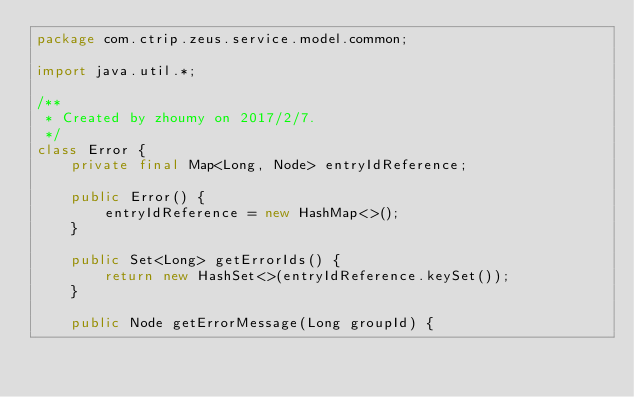<code> <loc_0><loc_0><loc_500><loc_500><_Java_>package com.ctrip.zeus.service.model.common;

import java.util.*;

/**
 * Created by zhoumy on 2017/2/7.
 */
class Error {
    private final Map<Long, Node> entryIdReference;

    public Error() {
        entryIdReference = new HashMap<>();
    }

    public Set<Long> getErrorIds() {
        return new HashSet<>(entryIdReference.keySet());
    }

    public Node getErrorMessage(Long groupId) {</code> 